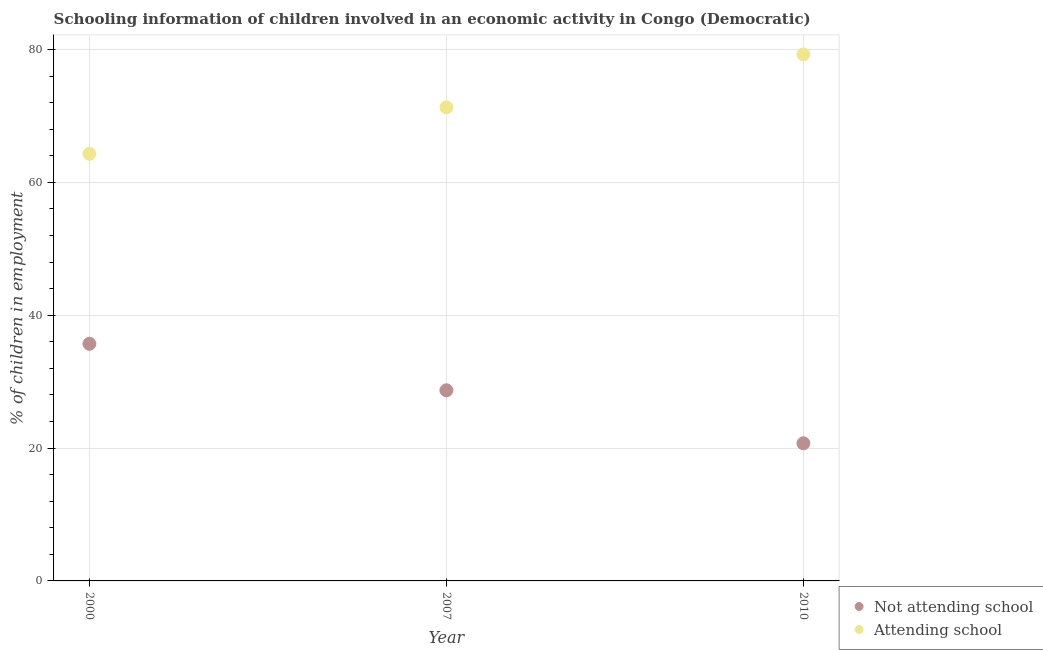How many different coloured dotlines are there?
Your response must be concise. 2. Is the number of dotlines equal to the number of legend labels?
Give a very brief answer. Yes. What is the percentage of employed children who are not attending school in 2010?
Provide a succinct answer. 20.72. Across all years, what is the maximum percentage of employed children who are not attending school?
Your answer should be compact. 35.7. Across all years, what is the minimum percentage of employed children who are not attending school?
Provide a short and direct response. 20.72. In which year was the percentage of employed children who are not attending school maximum?
Give a very brief answer. 2000. What is the total percentage of employed children who are not attending school in the graph?
Ensure brevity in your answer.  85.12. What is the difference between the percentage of employed children who are attending school in 2000 and that in 2007?
Ensure brevity in your answer.  -7. What is the difference between the percentage of employed children who are not attending school in 2010 and the percentage of employed children who are attending school in 2000?
Your answer should be compact. -43.58. What is the average percentage of employed children who are not attending school per year?
Your answer should be compact. 28.37. In the year 2010, what is the difference between the percentage of employed children who are attending school and percentage of employed children who are not attending school?
Provide a succinct answer. 58.56. What is the ratio of the percentage of employed children who are not attending school in 2000 to that in 2007?
Provide a succinct answer. 1.24. Is the percentage of employed children who are not attending school in 2000 less than that in 2010?
Provide a succinct answer. No. What is the difference between the highest and the second highest percentage of employed children who are attending school?
Your answer should be compact. 7.98. What is the difference between the highest and the lowest percentage of employed children who are not attending school?
Make the answer very short. 14.98. In how many years, is the percentage of employed children who are attending school greater than the average percentage of employed children who are attending school taken over all years?
Give a very brief answer. 1. Is the sum of the percentage of employed children who are attending school in 2000 and 2007 greater than the maximum percentage of employed children who are not attending school across all years?
Keep it short and to the point. Yes. Does the percentage of employed children who are not attending school monotonically increase over the years?
Offer a very short reply. No. How many dotlines are there?
Make the answer very short. 2. How many years are there in the graph?
Provide a succinct answer. 3. What is the difference between two consecutive major ticks on the Y-axis?
Provide a short and direct response. 20. Are the values on the major ticks of Y-axis written in scientific E-notation?
Ensure brevity in your answer.  No. Does the graph contain any zero values?
Offer a terse response. No. Where does the legend appear in the graph?
Provide a succinct answer. Bottom right. How many legend labels are there?
Your response must be concise. 2. How are the legend labels stacked?
Keep it short and to the point. Vertical. What is the title of the graph?
Offer a very short reply. Schooling information of children involved in an economic activity in Congo (Democratic). What is the label or title of the X-axis?
Keep it short and to the point. Year. What is the label or title of the Y-axis?
Keep it short and to the point. % of children in employment. What is the % of children in employment in Not attending school in 2000?
Your response must be concise. 35.7. What is the % of children in employment of Attending school in 2000?
Make the answer very short. 64.3. What is the % of children in employment in Not attending school in 2007?
Provide a short and direct response. 28.7. What is the % of children in employment in Attending school in 2007?
Keep it short and to the point. 71.3. What is the % of children in employment in Not attending school in 2010?
Offer a terse response. 20.72. What is the % of children in employment of Attending school in 2010?
Your response must be concise. 79.28. Across all years, what is the maximum % of children in employment of Not attending school?
Provide a short and direct response. 35.7. Across all years, what is the maximum % of children in employment of Attending school?
Provide a succinct answer. 79.28. Across all years, what is the minimum % of children in employment of Not attending school?
Your response must be concise. 20.72. Across all years, what is the minimum % of children in employment in Attending school?
Your response must be concise. 64.3. What is the total % of children in employment of Not attending school in the graph?
Offer a terse response. 85.12. What is the total % of children in employment of Attending school in the graph?
Your answer should be compact. 214.88. What is the difference between the % of children in employment in Not attending school in 2000 and that in 2007?
Your response must be concise. 7. What is the difference between the % of children in employment in Not attending school in 2000 and that in 2010?
Your answer should be compact. 14.98. What is the difference between the % of children in employment in Attending school in 2000 and that in 2010?
Ensure brevity in your answer.  -14.98. What is the difference between the % of children in employment of Not attending school in 2007 and that in 2010?
Keep it short and to the point. 7.98. What is the difference between the % of children in employment in Attending school in 2007 and that in 2010?
Provide a succinct answer. -7.98. What is the difference between the % of children in employment of Not attending school in 2000 and the % of children in employment of Attending school in 2007?
Your answer should be compact. -35.6. What is the difference between the % of children in employment of Not attending school in 2000 and the % of children in employment of Attending school in 2010?
Keep it short and to the point. -43.58. What is the difference between the % of children in employment in Not attending school in 2007 and the % of children in employment in Attending school in 2010?
Give a very brief answer. -50.58. What is the average % of children in employment in Not attending school per year?
Keep it short and to the point. 28.37. What is the average % of children in employment of Attending school per year?
Your answer should be very brief. 71.63. In the year 2000, what is the difference between the % of children in employment of Not attending school and % of children in employment of Attending school?
Offer a terse response. -28.6. In the year 2007, what is the difference between the % of children in employment in Not attending school and % of children in employment in Attending school?
Offer a terse response. -42.6. In the year 2010, what is the difference between the % of children in employment of Not attending school and % of children in employment of Attending school?
Ensure brevity in your answer.  -58.56. What is the ratio of the % of children in employment in Not attending school in 2000 to that in 2007?
Offer a terse response. 1.24. What is the ratio of the % of children in employment in Attending school in 2000 to that in 2007?
Ensure brevity in your answer.  0.9. What is the ratio of the % of children in employment of Not attending school in 2000 to that in 2010?
Give a very brief answer. 1.72. What is the ratio of the % of children in employment in Attending school in 2000 to that in 2010?
Ensure brevity in your answer.  0.81. What is the ratio of the % of children in employment of Not attending school in 2007 to that in 2010?
Ensure brevity in your answer.  1.39. What is the ratio of the % of children in employment of Attending school in 2007 to that in 2010?
Keep it short and to the point. 0.9. What is the difference between the highest and the second highest % of children in employment in Not attending school?
Your response must be concise. 7. What is the difference between the highest and the second highest % of children in employment in Attending school?
Make the answer very short. 7.98. What is the difference between the highest and the lowest % of children in employment in Not attending school?
Your answer should be very brief. 14.98. What is the difference between the highest and the lowest % of children in employment of Attending school?
Your answer should be very brief. 14.98. 